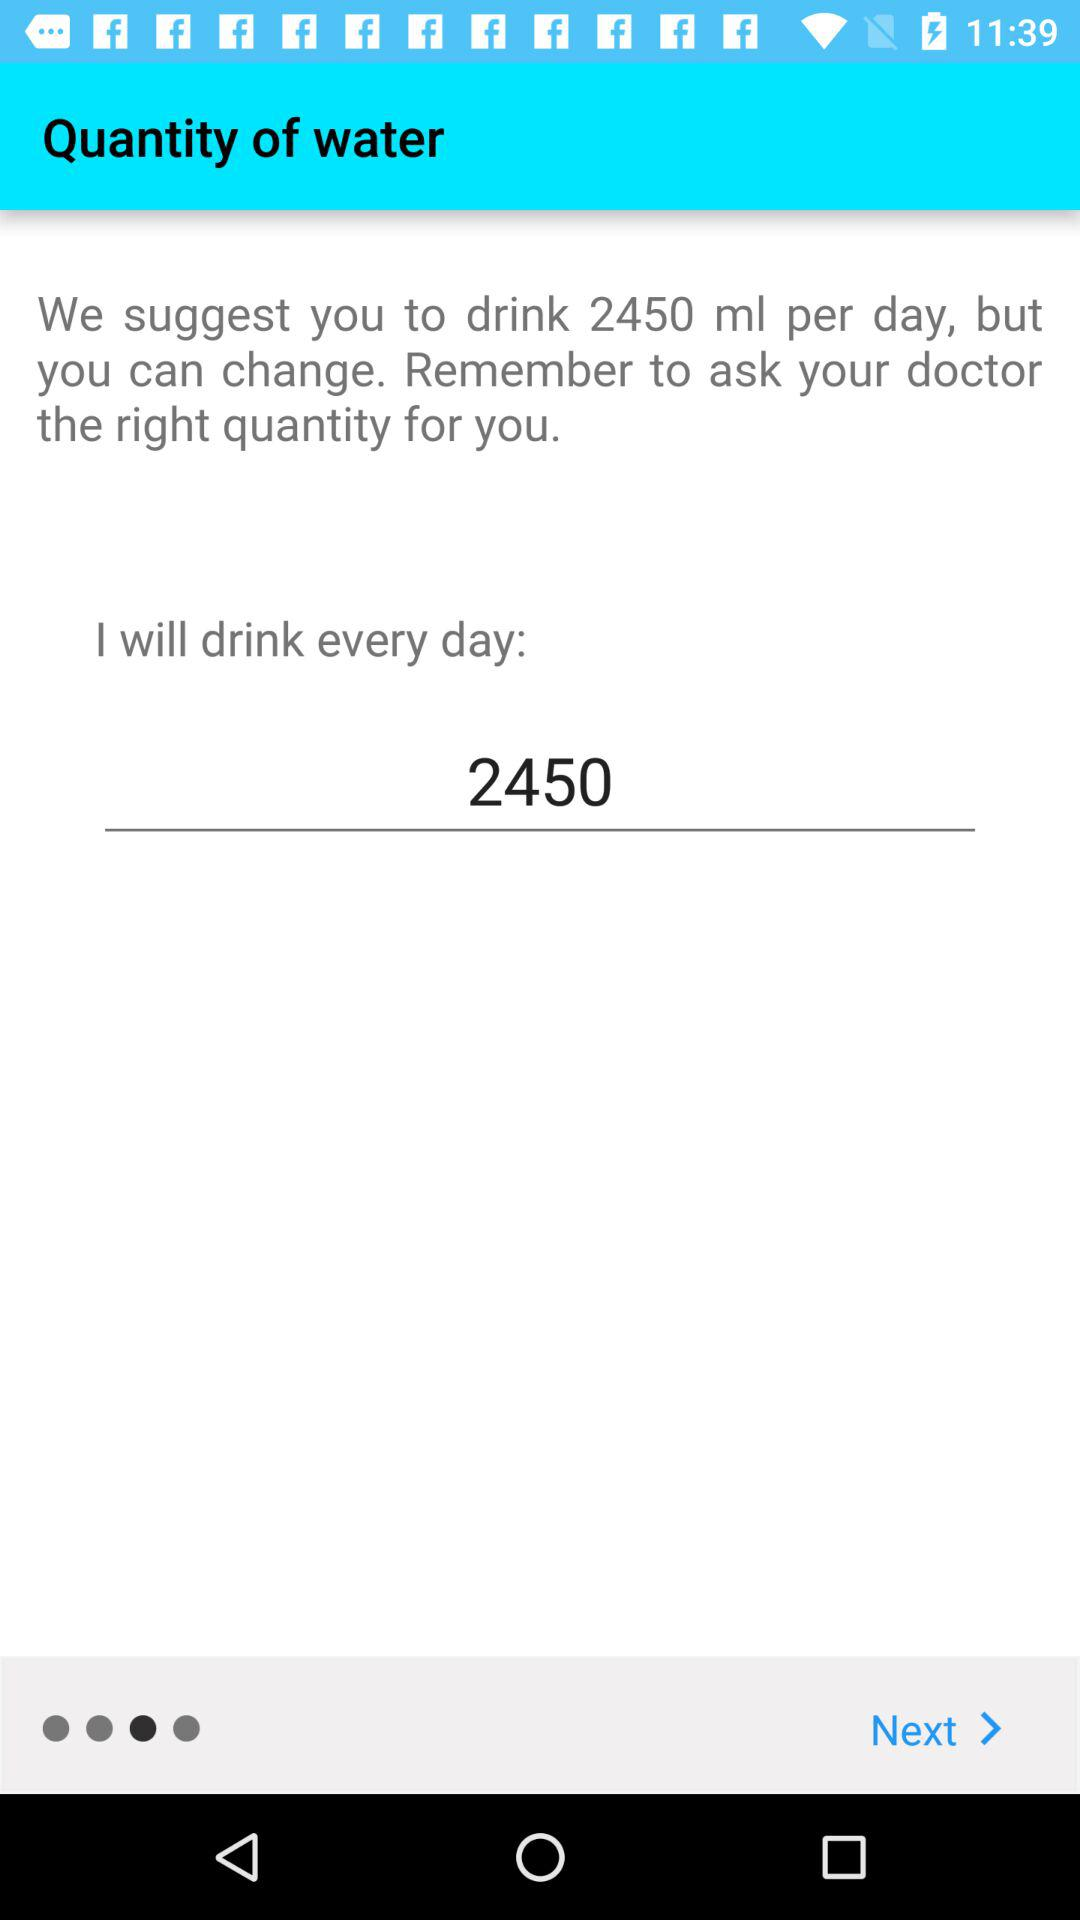How many ml should I drink per day if I follow the recommendation?
Answer the question using a single word or phrase. 2450 